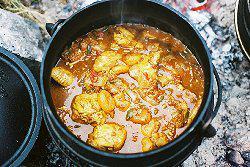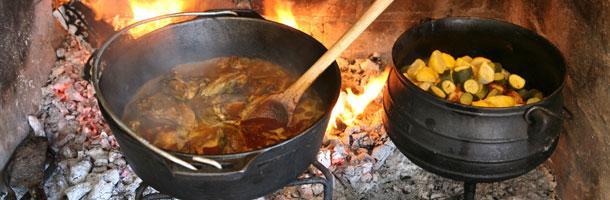The first image is the image on the left, the second image is the image on the right. For the images shown, is this caption "Food is on a plate in one of the images." true? Answer yes or no. No. The first image is the image on the left, the second image is the image on the right. Evaluate the accuracy of this statement regarding the images: "One image shows a one-pot meal in a round container with two handles that is not sitting on a heat source.". Is it true? Answer yes or no. No. 